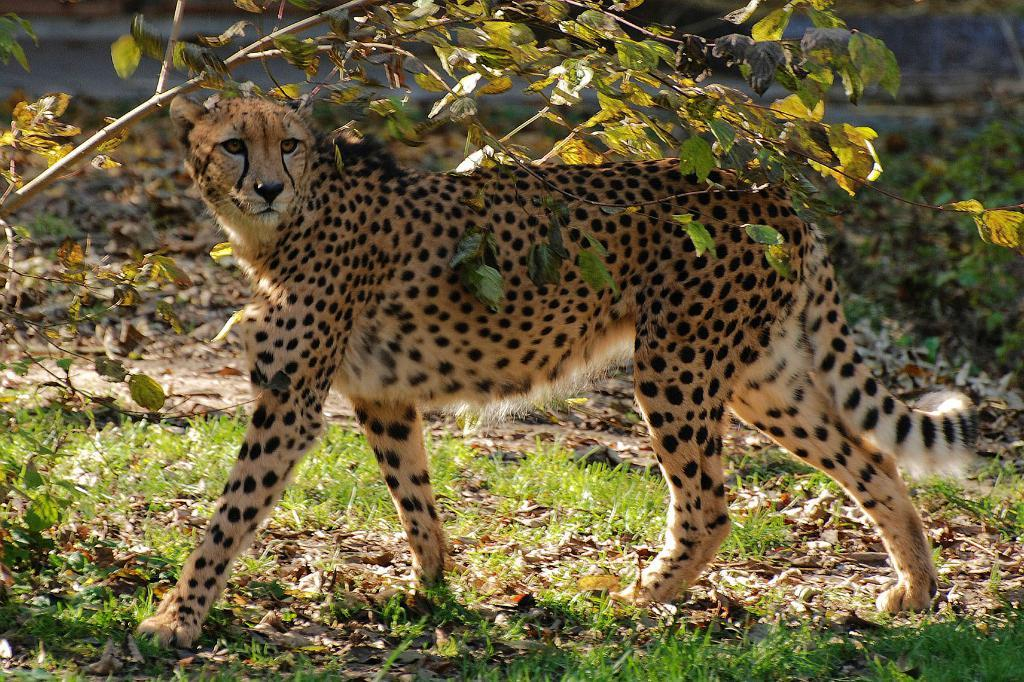What animal is the main subject of the image? There is a cheetah in the image. Where is the cheetah located? The cheetah is on the land. What type of vegetation can be seen in the image? There is grass on the ground in the image, and there are dried leaves as well. Can you describe any other natural features in the image? There is a small tree in the image. What decision did the cheetah make in the image? The image does not depict the cheetah making a decision, as it is a still photograph. What appliance can be seen in the image? There are no appliances present in the image; it features a cheetah, grass, dried leaves, and a small tree. 